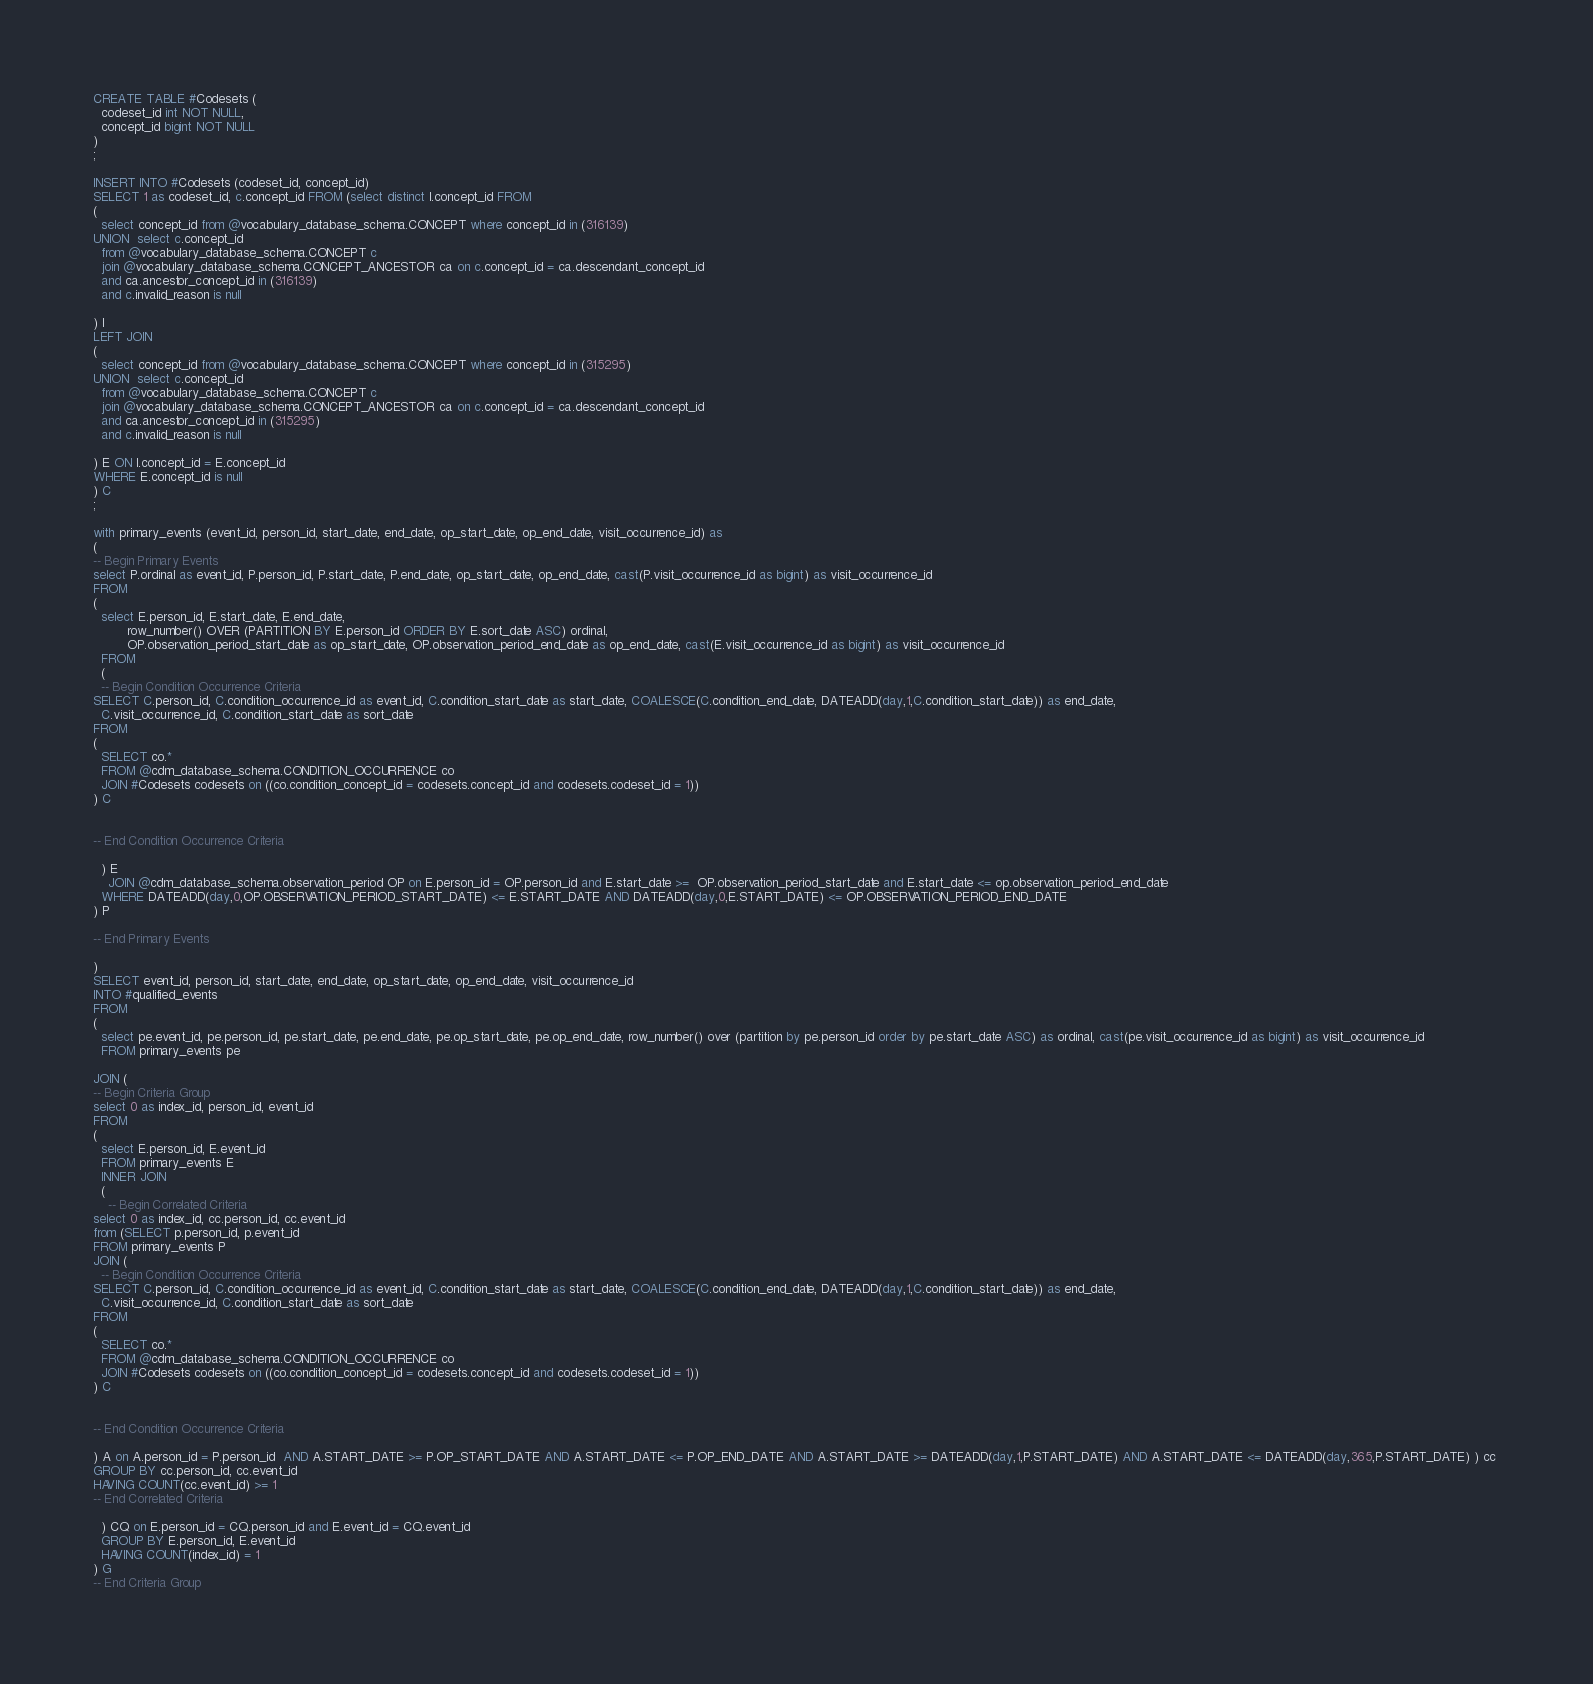Convert code to text. <code><loc_0><loc_0><loc_500><loc_500><_SQL_>CREATE TABLE #Codesets (
  codeset_id int NOT NULL,
  concept_id bigint NOT NULL
)
;

INSERT INTO #Codesets (codeset_id, concept_id)
SELECT 1 as codeset_id, c.concept_id FROM (select distinct I.concept_id FROM
( 
  select concept_id from @vocabulary_database_schema.CONCEPT where concept_id in (316139)
UNION  select c.concept_id
  from @vocabulary_database_schema.CONCEPT c
  join @vocabulary_database_schema.CONCEPT_ANCESTOR ca on c.concept_id = ca.descendant_concept_id
  and ca.ancestor_concept_id in (316139)
  and c.invalid_reason is null

) I
LEFT JOIN
(
  select concept_id from @vocabulary_database_schema.CONCEPT where concept_id in (315295)
UNION  select c.concept_id
  from @vocabulary_database_schema.CONCEPT c
  join @vocabulary_database_schema.CONCEPT_ANCESTOR ca on c.concept_id = ca.descendant_concept_id
  and ca.ancestor_concept_id in (315295)
  and c.invalid_reason is null

) E ON I.concept_id = E.concept_id
WHERE E.concept_id is null
) C
;

with primary_events (event_id, person_id, start_date, end_date, op_start_date, op_end_date, visit_occurrence_id) as
(
-- Begin Primary Events
select P.ordinal as event_id, P.person_id, P.start_date, P.end_date, op_start_date, op_end_date, cast(P.visit_occurrence_id as bigint) as visit_occurrence_id
FROM
(
  select E.person_id, E.start_date, E.end_date,
         row_number() OVER (PARTITION BY E.person_id ORDER BY E.sort_date ASC) ordinal,
         OP.observation_period_start_date as op_start_date, OP.observation_period_end_date as op_end_date, cast(E.visit_occurrence_id as bigint) as visit_occurrence_id
  FROM 
  (
  -- Begin Condition Occurrence Criteria
SELECT C.person_id, C.condition_occurrence_id as event_id, C.condition_start_date as start_date, COALESCE(C.condition_end_date, DATEADD(day,1,C.condition_start_date)) as end_date,
  C.visit_occurrence_id, C.condition_start_date as sort_date
FROM 
(
  SELECT co.* 
  FROM @cdm_database_schema.CONDITION_OCCURRENCE co
  JOIN #Codesets codesets on ((co.condition_concept_id = codesets.concept_id and codesets.codeset_id = 1))
) C


-- End Condition Occurrence Criteria

  ) E
	JOIN @cdm_database_schema.observation_period OP on E.person_id = OP.person_id and E.start_date >=  OP.observation_period_start_date and E.start_date <= op.observation_period_end_date
  WHERE DATEADD(day,0,OP.OBSERVATION_PERIOD_START_DATE) <= E.START_DATE AND DATEADD(day,0,E.START_DATE) <= OP.OBSERVATION_PERIOD_END_DATE
) P

-- End Primary Events

)
SELECT event_id, person_id, start_date, end_date, op_start_date, op_end_date, visit_occurrence_id
INTO #qualified_events
FROM 
(
  select pe.event_id, pe.person_id, pe.start_date, pe.end_date, pe.op_start_date, pe.op_end_date, row_number() over (partition by pe.person_id order by pe.start_date ASC) as ordinal, cast(pe.visit_occurrence_id as bigint) as visit_occurrence_id
  FROM primary_events pe
  
JOIN (
-- Begin Criteria Group
select 0 as index_id, person_id, event_id
FROM
(
  select E.person_id, E.event_id 
  FROM primary_events E
  INNER JOIN
  (
    -- Begin Correlated Criteria
select 0 as index_id, cc.person_id, cc.event_id
from (SELECT p.person_id, p.event_id 
FROM primary_events P
JOIN (
  -- Begin Condition Occurrence Criteria
SELECT C.person_id, C.condition_occurrence_id as event_id, C.condition_start_date as start_date, COALESCE(C.condition_end_date, DATEADD(day,1,C.condition_start_date)) as end_date,
  C.visit_occurrence_id, C.condition_start_date as sort_date
FROM 
(
  SELECT co.* 
  FROM @cdm_database_schema.CONDITION_OCCURRENCE co
  JOIN #Codesets codesets on ((co.condition_concept_id = codesets.concept_id and codesets.codeset_id = 1))
) C


-- End Condition Occurrence Criteria

) A on A.person_id = P.person_id  AND A.START_DATE >= P.OP_START_DATE AND A.START_DATE <= P.OP_END_DATE AND A.START_DATE >= DATEADD(day,1,P.START_DATE) AND A.START_DATE <= DATEADD(day,365,P.START_DATE) ) cc 
GROUP BY cc.person_id, cc.event_id
HAVING COUNT(cc.event_id) >= 1
-- End Correlated Criteria

  ) CQ on E.person_id = CQ.person_id and E.event_id = CQ.event_id
  GROUP BY E.person_id, E.event_id
  HAVING COUNT(index_id) = 1
) G
-- End Criteria Group</code> 